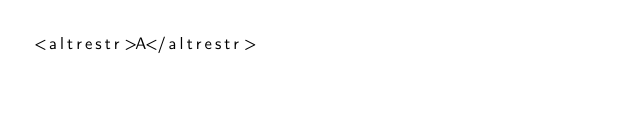Convert code to text. <code><loc_0><loc_0><loc_500><loc_500><_XML_><altrestr>A</altrestr>
</code> 